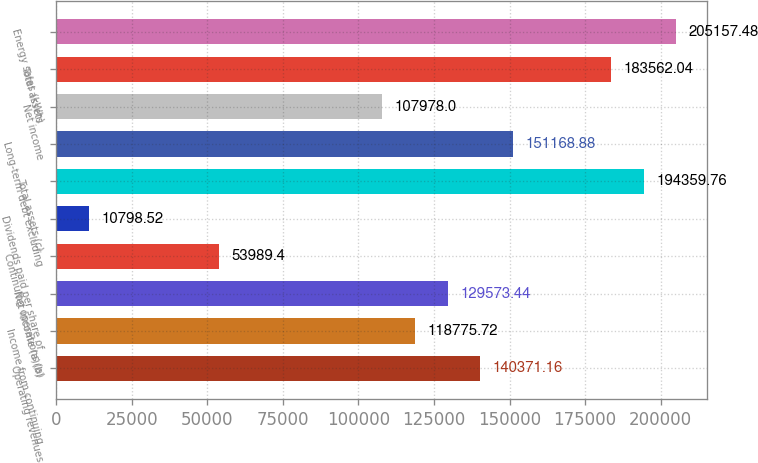Convert chart. <chart><loc_0><loc_0><loc_500><loc_500><bar_chart><fcel>Operating revenues<fcel>Income from continuing<fcel>Net income (a)(b)<fcel>Continuing operations (a)<fcel>Dividends paid per share of<fcel>Total assets (c)<fcel>Long-term debt excluding<fcel>Net income<fcel>Total assets<fcel>Energy sales (kWh)<nl><fcel>140371<fcel>118776<fcel>129573<fcel>53989.4<fcel>10798.5<fcel>194360<fcel>151169<fcel>107978<fcel>183562<fcel>205157<nl></chart> 